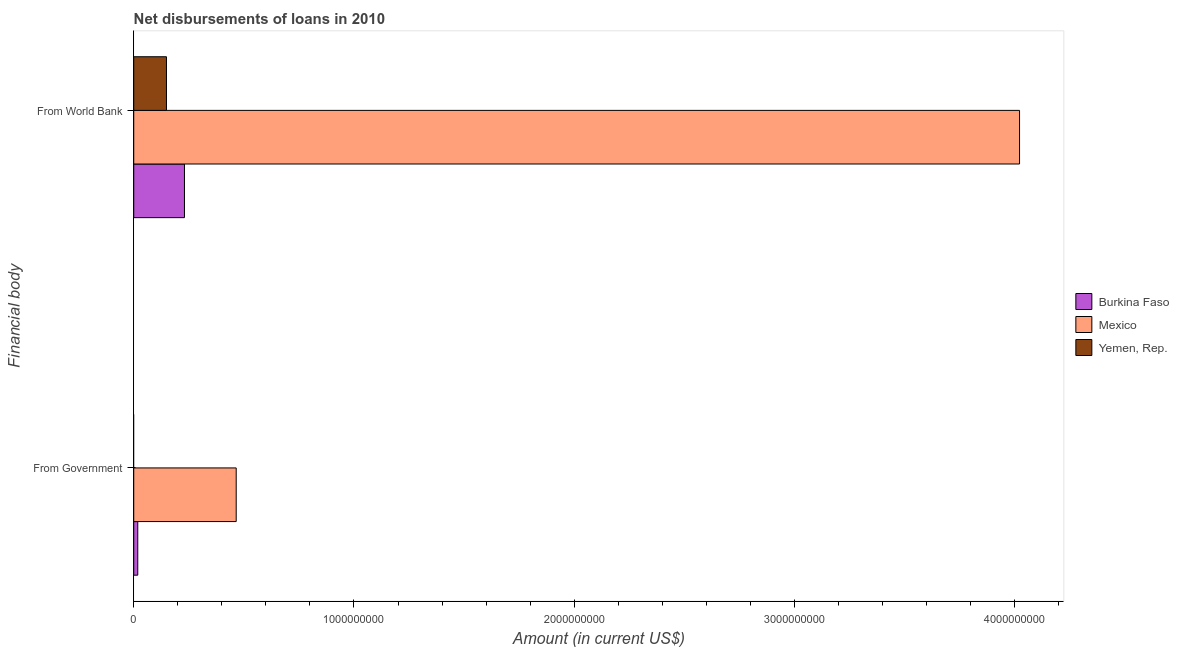How many groups of bars are there?
Your answer should be compact. 2. Are the number of bars on each tick of the Y-axis equal?
Offer a very short reply. No. How many bars are there on the 1st tick from the top?
Make the answer very short. 3. What is the label of the 1st group of bars from the top?
Your answer should be compact. From World Bank. What is the net disbursements of loan from government in Burkina Faso?
Offer a very short reply. 1.83e+07. Across all countries, what is the maximum net disbursements of loan from world bank?
Provide a short and direct response. 4.02e+09. Across all countries, what is the minimum net disbursements of loan from world bank?
Provide a short and direct response. 1.49e+08. What is the total net disbursements of loan from world bank in the graph?
Your answer should be compact. 4.40e+09. What is the difference between the net disbursements of loan from world bank in Yemen, Rep. and that in Burkina Faso?
Your answer should be compact. -8.18e+07. What is the difference between the net disbursements of loan from world bank in Yemen, Rep. and the net disbursements of loan from government in Burkina Faso?
Provide a succinct answer. 1.30e+08. What is the average net disbursements of loan from government per country?
Provide a short and direct response. 1.61e+08. What is the difference between the net disbursements of loan from world bank and net disbursements of loan from government in Burkina Faso?
Offer a very short reply. 2.12e+08. What is the ratio of the net disbursements of loan from world bank in Mexico to that in Yemen, Rep.?
Keep it short and to the point. 27.07. In how many countries, is the net disbursements of loan from world bank greater than the average net disbursements of loan from world bank taken over all countries?
Your response must be concise. 1. Does the graph contain grids?
Give a very brief answer. No. How many legend labels are there?
Keep it short and to the point. 3. How are the legend labels stacked?
Keep it short and to the point. Vertical. What is the title of the graph?
Provide a succinct answer. Net disbursements of loans in 2010. Does "Saudi Arabia" appear as one of the legend labels in the graph?
Keep it short and to the point. No. What is the label or title of the X-axis?
Give a very brief answer. Amount (in current US$). What is the label or title of the Y-axis?
Offer a terse response. Financial body. What is the Amount (in current US$) in Burkina Faso in From Government?
Your answer should be very brief. 1.83e+07. What is the Amount (in current US$) in Mexico in From Government?
Give a very brief answer. 4.65e+08. What is the Amount (in current US$) of Burkina Faso in From World Bank?
Your response must be concise. 2.30e+08. What is the Amount (in current US$) of Mexico in From World Bank?
Give a very brief answer. 4.02e+09. What is the Amount (in current US$) in Yemen, Rep. in From World Bank?
Your response must be concise. 1.49e+08. Across all Financial body, what is the maximum Amount (in current US$) of Burkina Faso?
Your answer should be very brief. 2.30e+08. Across all Financial body, what is the maximum Amount (in current US$) of Mexico?
Keep it short and to the point. 4.02e+09. Across all Financial body, what is the maximum Amount (in current US$) of Yemen, Rep.?
Keep it short and to the point. 1.49e+08. Across all Financial body, what is the minimum Amount (in current US$) of Burkina Faso?
Ensure brevity in your answer.  1.83e+07. Across all Financial body, what is the minimum Amount (in current US$) of Mexico?
Your answer should be compact. 4.65e+08. What is the total Amount (in current US$) in Burkina Faso in the graph?
Keep it short and to the point. 2.49e+08. What is the total Amount (in current US$) in Mexico in the graph?
Make the answer very short. 4.49e+09. What is the total Amount (in current US$) in Yemen, Rep. in the graph?
Provide a short and direct response. 1.49e+08. What is the difference between the Amount (in current US$) in Burkina Faso in From Government and that in From World Bank?
Offer a very short reply. -2.12e+08. What is the difference between the Amount (in current US$) of Mexico in From Government and that in From World Bank?
Your answer should be compact. -3.56e+09. What is the difference between the Amount (in current US$) in Burkina Faso in From Government and the Amount (in current US$) in Mexico in From World Bank?
Your answer should be compact. -4.00e+09. What is the difference between the Amount (in current US$) of Burkina Faso in From Government and the Amount (in current US$) of Yemen, Rep. in From World Bank?
Give a very brief answer. -1.30e+08. What is the difference between the Amount (in current US$) of Mexico in From Government and the Amount (in current US$) of Yemen, Rep. in From World Bank?
Ensure brevity in your answer.  3.17e+08. What is the average Amount (in current US$) of Burkina Faso per Financial body?
Make the answer very short. 1.24e+08. What is the average Amount (in current US$) in Mexico per Financial body?
Offer a very short reply. 2.24e+09. What is the average Amount (in current US$) of Yemen, Rep. per Financial body?
Ensure brevity in your answer.  7.43e+07. What is the difference between the Amount (in current US$) of Burkina Faso and Amount (in current US$) of Mexico in From Government?
Your answer should be very brief. -4.47e+08. What is the difference between the Amount (in current US$) in Burkina Faso and Amount (in current US$) in Mexico in From World Bank?
Your response must be concise. -3.79e+09. What is the difference between the Amount (in current US$) of Burkina Faso and Amount (in current US$) of Yemen, Rep. in From World Bank?
Keep it short and to the point. 8.18e+07. What is the difference between the Amount (in current US$) of Mexico and Amount (in current US$) of Yemen, Rep. in From World Bank?
Keep it short and to the point. 3.87e+09. What is the ratio of the Amount (in current US$) in Burkina Faso in From Government to that in From World Bank?
Offer a terse response. 0.08. What is the ratio of the Amount (in current US$) of Mexico in From Government to that in From World Bank?
Provide a succinct answer. 0.12. What is the difference between the highest and the second highest Amount (in current US$) in Burkina Faso?
Your answer should be compact. 2.12e+08. What is the difference between the highest and the second highest Amount (in current US$) of Mexico?
Offer a terse response. 3.56e+09. What is the difference between the highest and the lowest Amount (in current US$) in Burkina Faso?
Your answer should be compact. 2.12e+08. What is the difference between the highest and the lowest Amount (in current US$) of Mexico?
Your answer should be compact. 3.56e+09. What is the difference between the highest and the lowest Amount (in current US$) in Yemen, Rep.?
Provide a short and direct response. 1.49e+08. 